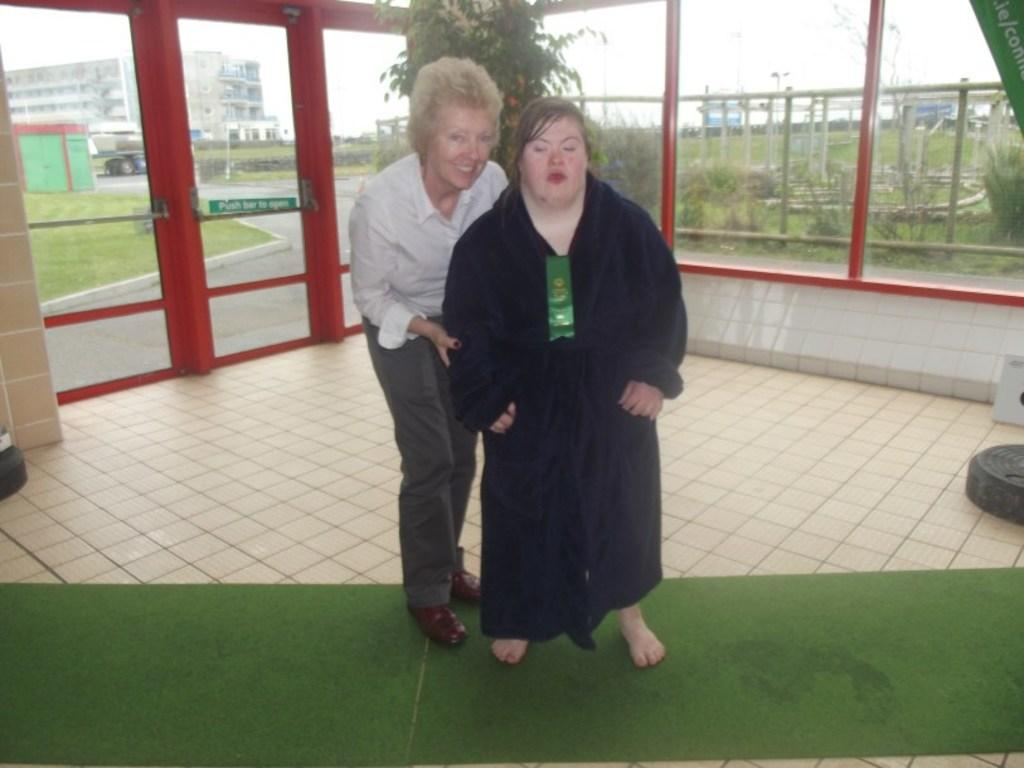What is the main subject of the image? There is a woman standing in the middle of the image. Can you describe the woman's attire? The woman is wearing a black dress. Who is beside the woman in the image? There is another woman beside her. How is the second woman's expression? The second woman is smiling. What is the second woman wearing? The second woman is wearing a white shirt. What can be seen in the background of the image? There is a plant and a glass wall visible in the background. What type of act are the women performing in the image? There is no act being performed in the image; the women are simply standing and smiling. Can you describe the exchange between the women in the image? There is no exchange between the women in the image; they are not interacting with each other. 